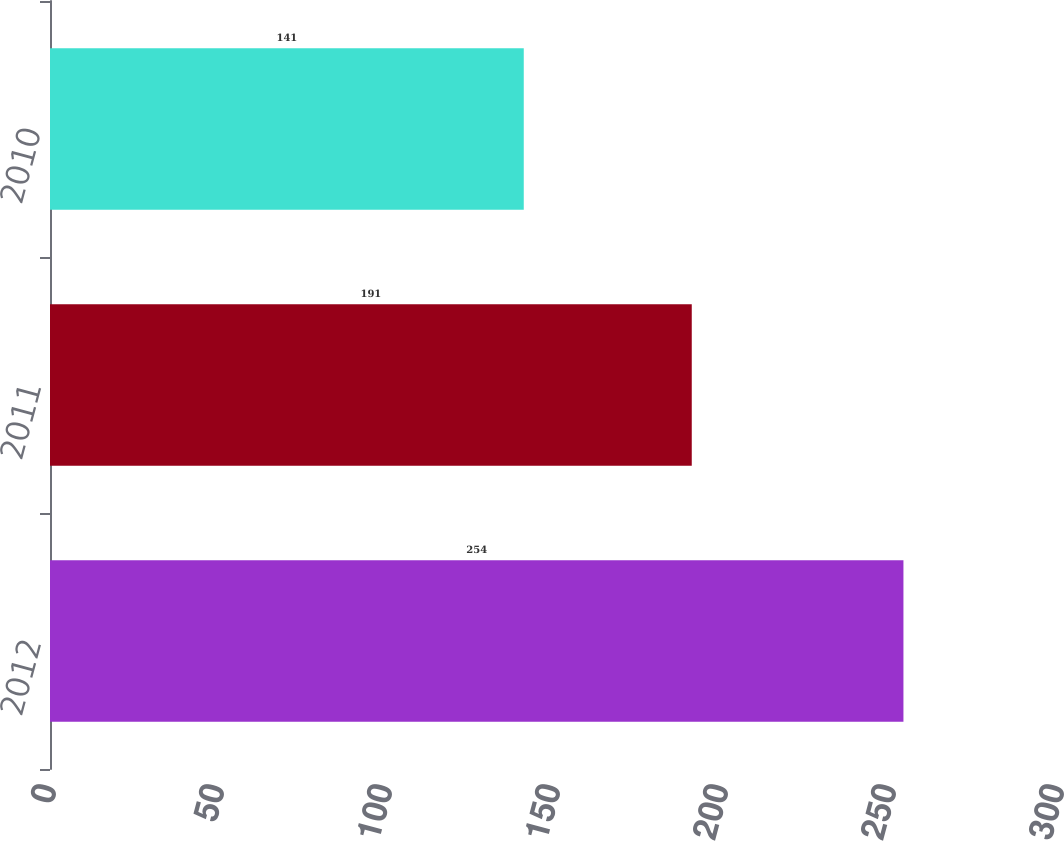Convert chart to OTSL. <chart><loc_0><loc_0><loc_500><loc_500><bar_chart><fcel>2012<fcel>2011<fcel>2010<nl><fcel>254<fcel>191<fcel>141<nl></chart> 